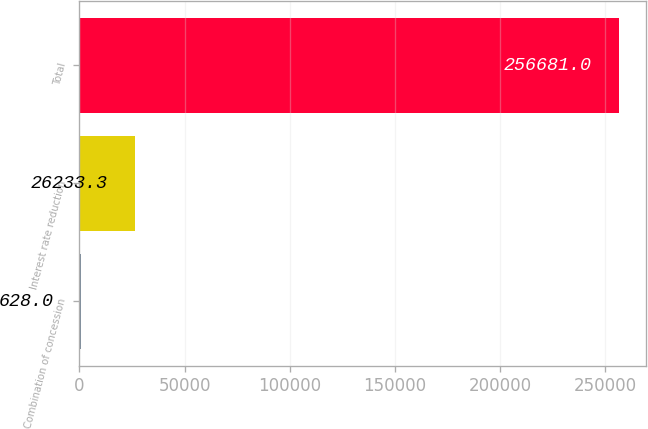Convert chart to OTSL. <chart><loc_0><loc_0><loc_500><loc_500><bar_chart><fcel>Combination of concession<fcel>Interest rate reduction<fcel>Total<nl><fcel>628<fcel>26233.3<fcel>256681<nl></chart> 